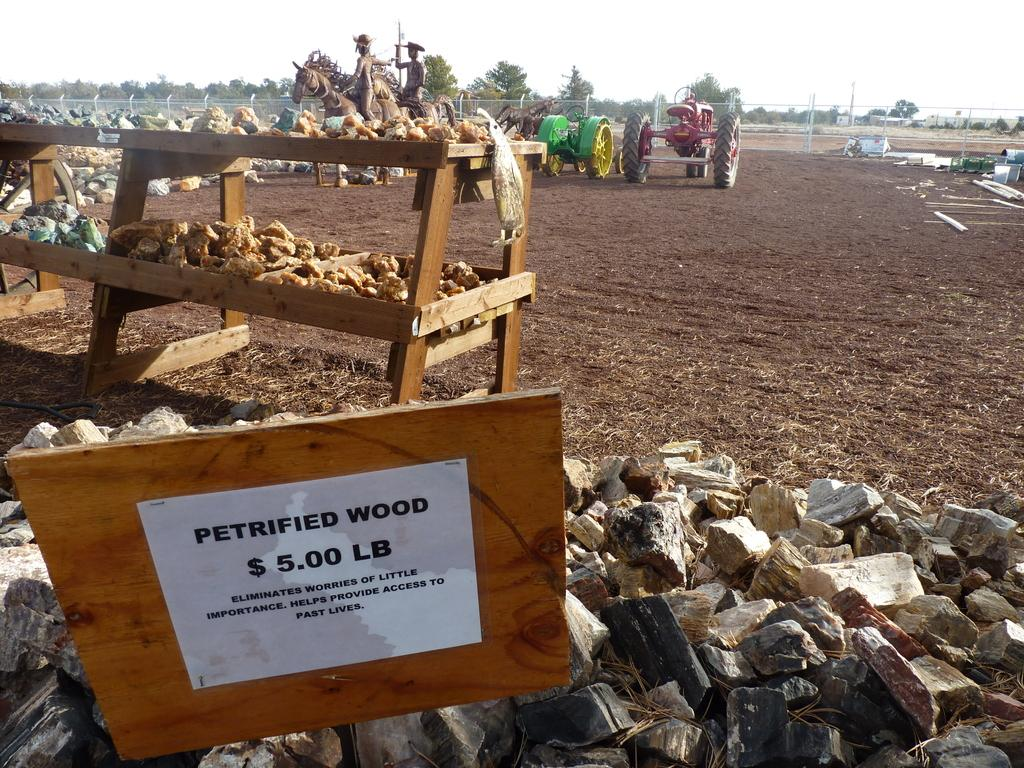<image>
Relay a brief, clear account of the picture shown. Large hay and grass area with a sign that says petrified wood is $5.00. 